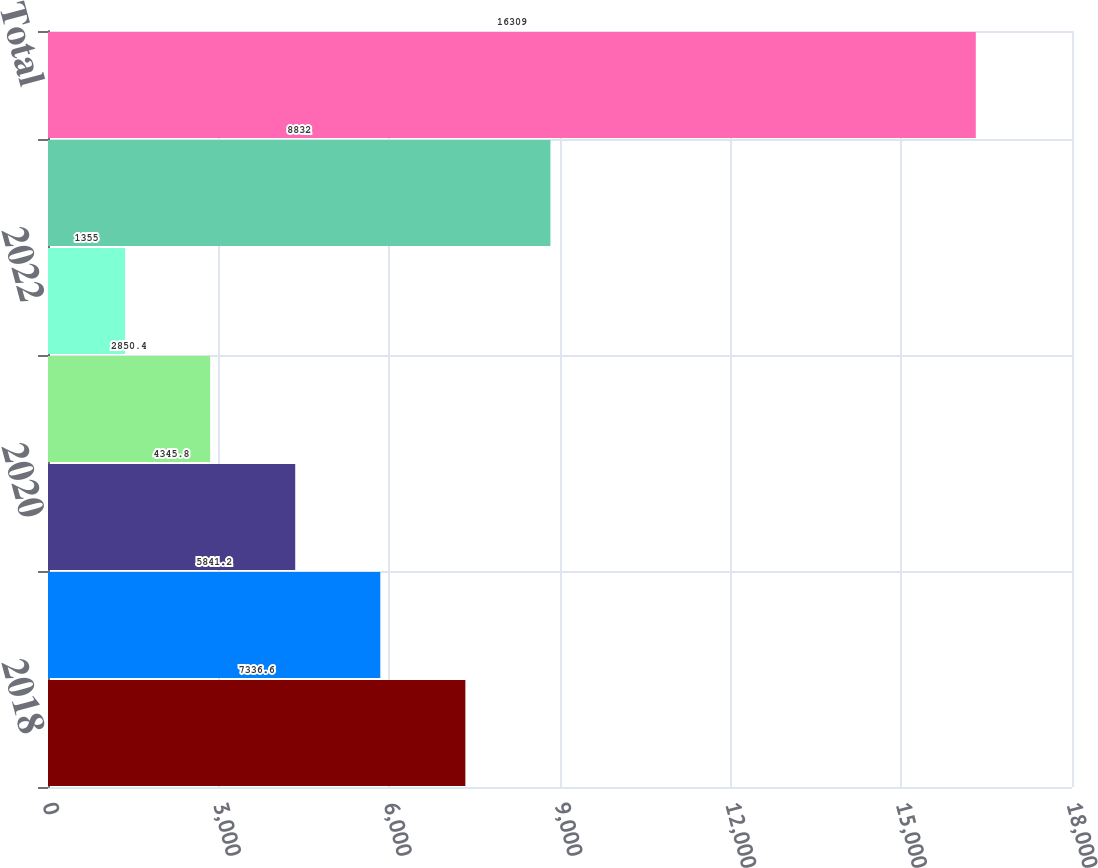<chart> <loc_0><loc_0><loc_500><loc_500><bar_chart><fcel>2018<fcel>2019<fcel>2020<fcel>2021<fcel>2022<fcel>Thereafter<fcel>Total<nl><fcel>7336.6<fcel>5841.2<fcel>4345.8<fcel>2850.4<fcel>1355<fcel>8832<fcel>16309<nl></chart> 